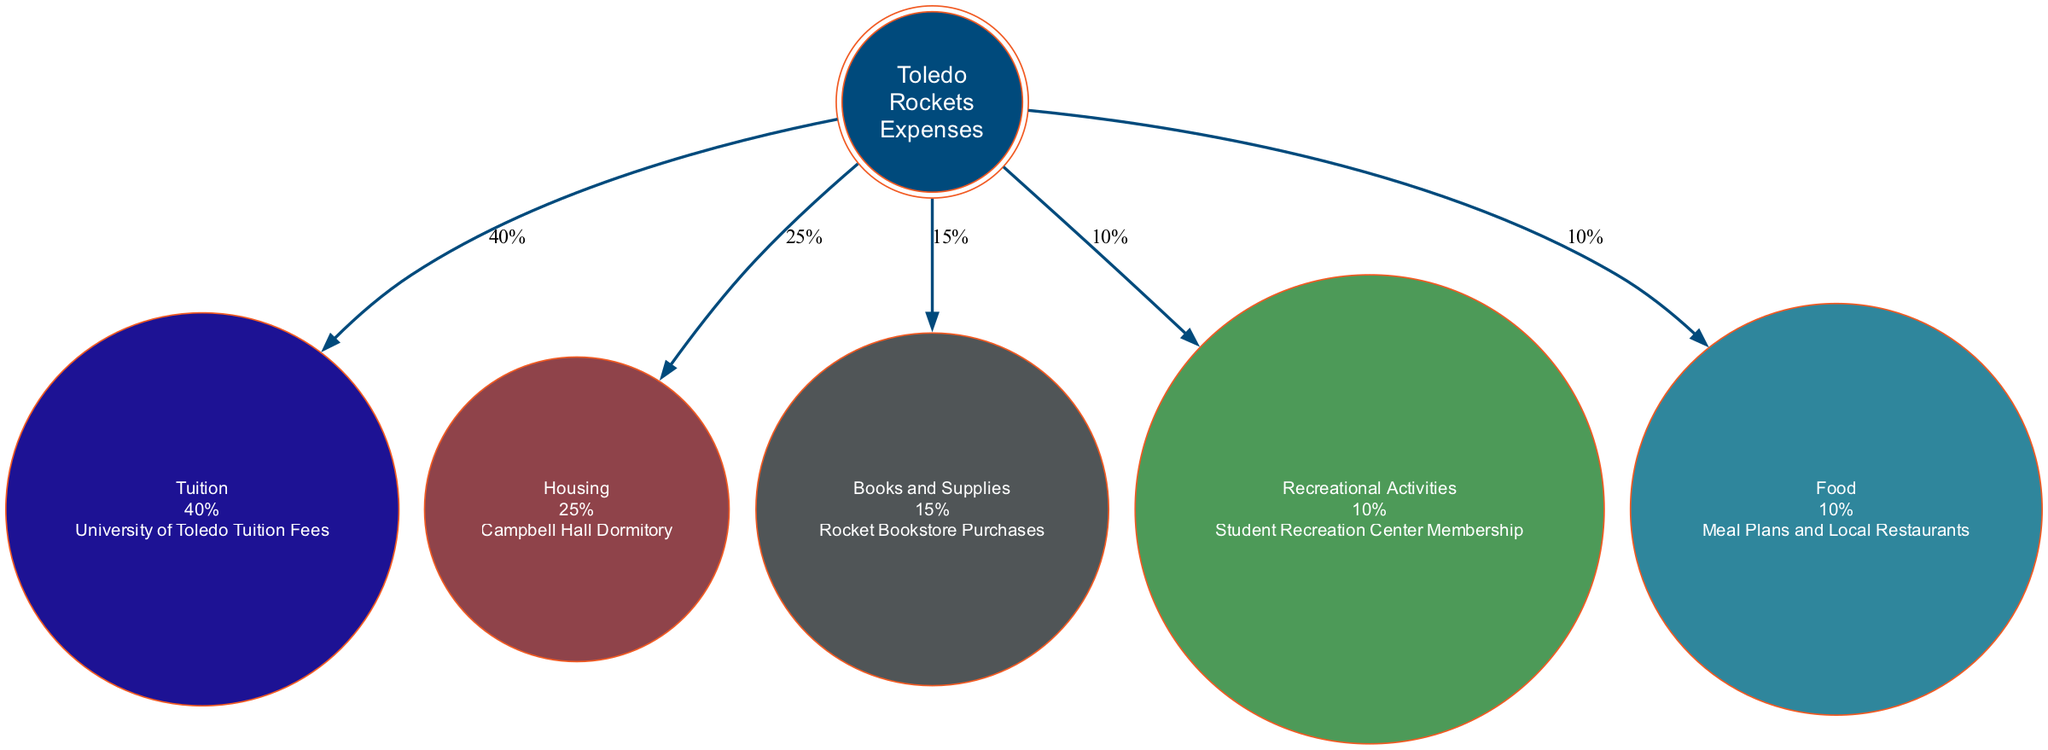What is the percentage of expenses for tuition? The diagram specifies that tuition accounts for 40% of the total expenses. This is directly stated in the section for the tuition category.
Answer: 40% Which category has the highest expense? By reviewing each category's percentage, tuition at 40% is the highest among all listed categories. This is a straightforward comparison.
Answer: Tuition How many total categories are shown in the diagram? The diagram includes five distinct expense categories: Tuition, Housing, Books and Supplies, Recreational Activities, and Food. This count can be easily derived from the categories listed.
Answer: 5 What detail is associated with the housing category? Referring to the housing category, it specifies that the detail is related to "Campbell Hall Dormitory." This is provided directly under the housing section.
Answer: Campbell Hall Dormitory Which expense category corresponds to 15%? The category for Books and Supplies is noted to correspond to 15% of the total expenses. This figure appears in the categorical representation of books and supplies.
Answer: Books and Supplies What is the combined percentage of food and recreational activities? By adding the percentages of food (10%) and recreational activities (10%), we find the combined total is 20%. This requires summing the two individual categories' percentages.
Answer: 20% Which expense is associated with meal plans and local restaurants? The food category explicitly mentions "Meal Plans and Local Restaurants" as its associated detail. This connection is made clear within the food section of the diagram.
Answer: Food What is the percentage of expenses for recreational activities? The diagram indicates that recreational activities account for 10% of total expenses, as clearly marked in that category's section.
Answer: 10% 